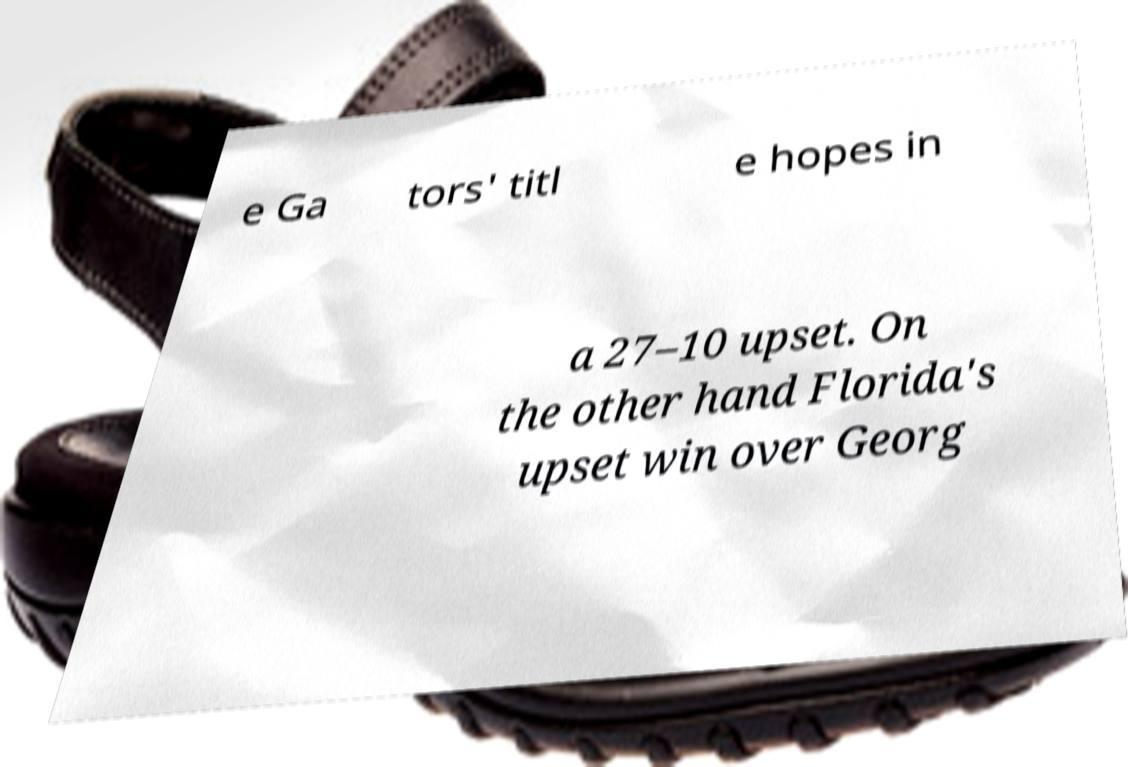What messages or text are displayed in this image? I need them in a readable, typed format. e Ga tors' titl e hopes in a 27–10 upset. On the other hand Florida's upset win over Georg 